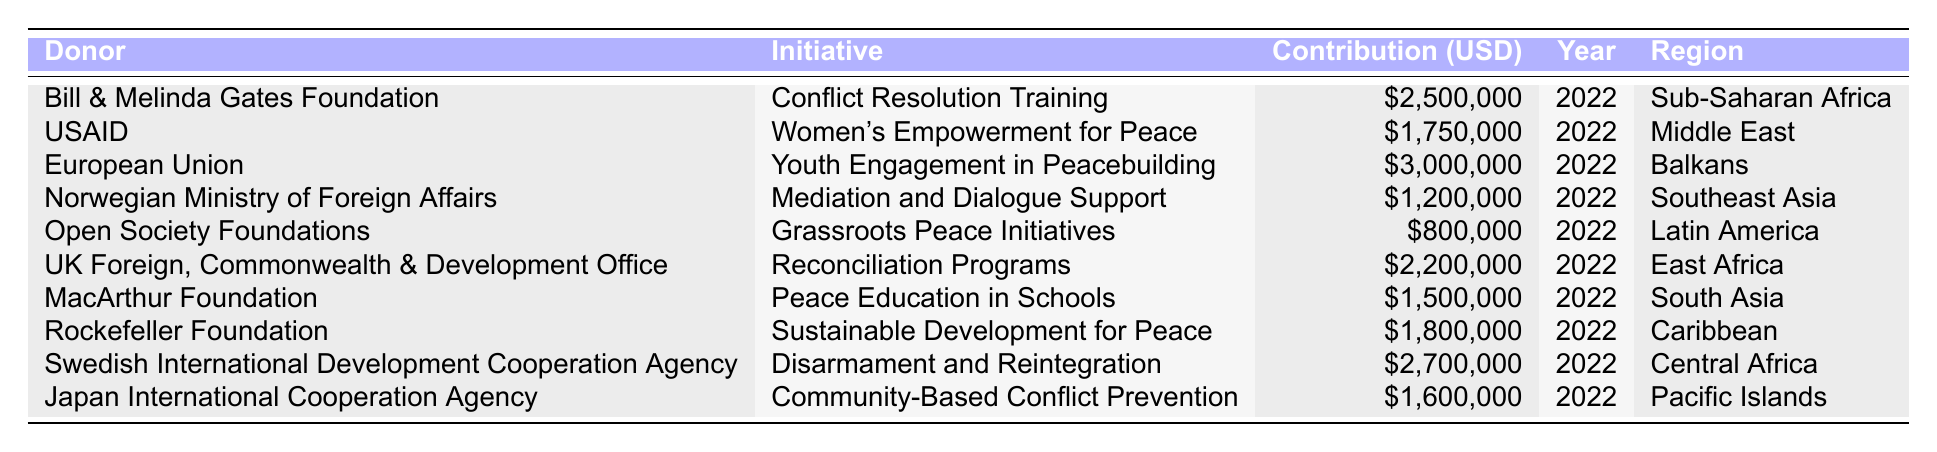What is the total contribution amount from all donors for the initiatives listed? To find the total contribution amount, sum up all the contribution amounts: \$2,500,000 + \$1,750,000 + \$3,000,000 + \$1,200,000 + \$800,000 + \$2,200,000 + \$1,500,000 + \$1,800,000 + \$2,700,000 + \$1,600,000 = \$19,050,000.
Answer: \$19,050,000 Which initiative received the highest contribution? The highest contribution is \$3,000,000 for the initiative "Youth Engagement in Peacebuilding" funded by the European Union.
Answer: Youth Engagement in Peacebuilding How many initiatives received contributions of over $2 million? The initiatives with contributions over $2 million are: "Conflict Resolution Training," "Youth Engagement in Peacebuilding," "Reconciliation Programs," and "Disarmament and Reintegration." There are 4 initiatives total.
Answer: 4 Did the Open Society Foundations contribute to any initiative? Yes, the Open Society Foundations contributed \$800,000 to "Grassroots Peace Initiatives."
Answer: Yes What is the average contribution amount for initiatives in Southeast Asia? There is one initiative in Southeast Asia - "Mediation and Dialogue Support" with a contribution of \$1,200,000. Therefore, the average is \$1,200,000 / 1 = \$1,200,000.
Answer: \$1,200,000 Which region received the least funding among the listed initiatives? The region with the least funding is Latin America with "Grassroots Peace Initiatives" receiving \$800,000.
Answer: Latin America How much more did the Swedish International Development Cooperation Agency contribute compared to the Norwegian Ministry of Foreign Affairs? Swedish International Development Cooperation Agency contributed \$2,700,000 and Norwegian Ministry of Foreign Affairs contributed \$1,200,000. The difference is \$2,700,000 - \$1,200,000 = \$1,500,000.
Answer: \$1,500,000 Which donor contributed to the initiative focused on women’s empowerment? USAID contributed \$1,750,000 to the "Women's Empowerment for Peace" initiative.
Answer: USAID What percentage of the total contributions does the contribution from the Bill & Melinda Gates Foundation represent? The Bill & Melinda Gates Foundation contributed \$2,500,000. The total contributions are \$19,050,000. The percentage is (\$2,500,000 / \$19,050,000) * 100 ≈ 13.13%.
Answer: Approximately 13.13% Is there any initiative that received contributions from more than one donor? No, each initiative listed is funded by a single donor according to the data provided.
Answer: No 